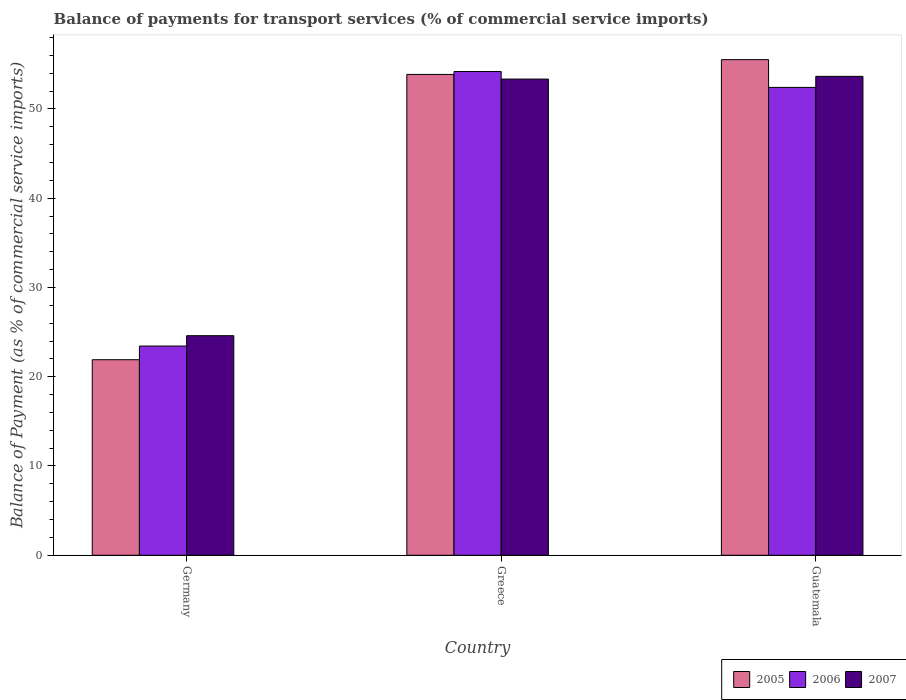How many groups of bars are there?
Give a very brief answer. 3. Are the number of bars per tick equal to the number of legend labels?
Your answer should be very brief. Yes. How many bars are there on the 1st tick from the left?
Provide a succinct answer. 3. How many bars are there on the 1st tick from the right?
Provide a succinct answer. 3. What is the label of the 3rd group of bars from the left?
Your answer should be very brief. Guatemala. In how many cases, is the number of bars for a given country not equal to the number of legend labels?
Your answer should be very brief. 0. What is the balance of payments for transport services in 2007 in Guatemala?
Make the answer very short. 53.64. Across all countries, what is the maximum balance of payments for transport services in 2007?
Keep it short and to the point. 53.64. Across all countries, what is the minimum balance of payments for transport services in 2007?
Your answer should be very brief. 24.6. In which country was the balance of payments for transport services in 2005 maximum?
Your answer should be very brief. Guatemala. What is the total balance of payments for transport services in 2006 in the graph?
Provide a short and direct response. 130.03. What is the difference between the balance of payments for transport services in 2006 in Greece and that in Guatemala?
Your response must be concise. 1.78. What is the difference between the balance of payments for transport services in 2006 in Greece and the balance of payments for transport services in 2005 in Germany?
Offer a very short reply. 32.28. What is the average balance of payments for transport services in 2006 per country?
Keep it short and to the point. 43.34. What is the difference between the balance of payments for transport services of/in 2007 and balance of payments for transport services of/in 2005 in Guatemala?
Provide a short and direct response. -1.87. In how many countries, is the balance of payments for transport services in 2006 greater than 22 %?
Make the answer very short. 3. What is the ratio of the balance of payments for transport services in 2006 in Germany to that in Greece?
Give a very brief answer. 0.43. What is the difference between the highest and the second highest balance of payments for transport services in 2005?
Make the answer very short. -31.95. What is the difference between the highest and the lowest balance of payments for transport services in 2005?
Make the answer very short. 33.61. In how many countries, is the balance of payments for transport services in 2005 greater than the average balance of payments for transport services in 2005 taken over all countries?
Your response must be concise. 2. Is the sum of the balance of payments for transport services in 2005 in Germany and Guatemala greater than the maximum balance of payments for transport services in 2007 across all countries?
Offer a very short reply. Yes. What does the 1st bar from the right in Guatemala represents?
Give a very brief answer. 2007. Is it the case that in every country, the sum of the balance of payments for transport services in 2006 and balance of payments for transport services in 2007 is greater than the balance of payments for transport services in 2005?
Offer a very short reply. Yes. How many bars are there?
Your answer should be very brief. 9. Are all the bars in the graph horizontal?
Provide a succinct answer. No. How many countries are there in the graph?
Provide a short and direct response. 3. Does the graph contain any zero values?
Offer a very short reply. No. Does the graph contain grids?
Offer a very short reply. No. Where does the legend appear in the graph?
Provide a succinct answer. Bottom right. How are the legend labels stacked?
Offer a terse response. Horizontal. What is the title of the graph?
Make the answer very short. Balance of payments for transport services (% of commercial service imports). What is the label or title of the Y-axis?
Make the answer very short. Balance of Payment (as % of commercial service imports). What is the Balance of Payment (as % of commercial service imports) in 2005 in Germany?
Make the answer very short. 21.91. What is the Balance of Payment (as % of commercial service imports) of 2006 in Germany?
Make the answer very short. 23.44. What is the Balance of Payment (as % of commercial service imports) in 2007 in Germany?
Keep it short and to the point. 24.6. What is the Balance of Payment (as % of commercial service imports) of 2005 in Greece?
Provide a succinct answer. 53.86. What is the Balance of Payment (as % of commercial service imports) in 2006 in Greece?
Your answer should be very brief. 54.19. What is the Balance of Payment (as % of commercial service imports) of 2007 in Greece?
Provide a succinct answer. 53.34. What is the Balance of Payment (as % of commercial service imports) in 2005 in Guatemala?
Provide a short and direct response. 55.52. What is the Balance of Payment (as % of commercial service imports) in 2006 in Guatemala?
Provide a short and direct response. 52.41. What is the Balance of Payment (as % of commercial service imports) in 2007 in Guatemala?
Provide a succinct answer. 53.64. Across all countries, what is the maximum Balance of Payment (as % of commercial service imports) of 2005?
Your answer should be compact. 55.52. Across all countries, what is the maximum Balance of Payment (as % of commercial service imports) of 2006?
Provide a short and direct response. 54.19. Across all countries, what is the maximum Balance of Payment (as % of commercial service imports) of 2007?
Provide a short and direct response. 53.64. Across all countries, what is the minimum Balance of Payment (as % of commercial service imports) in 2005?
Provide a short and direct response. 21.91. Across all countries, what is the minimum Balance of Payment (as % of commercial service imports) in 2006?
Offer a terse response. 23.44. Across all countries, what is the minimum Balance of Payment (as % of commercial service imports) of 2007?
Your answer should be compact. 24.6. What is the total Balance of Payment (as % of commercial service imports) in 2005 in the graph?
Give a very brief answer. 131.28. What is the total Balance of Payment (as % of commercial service imports) in 2006 in the graph?
Your answer should be compact. 130.03. What is the total Balance of Payment (as % of commercial service imports) of 2007 in the graph?
Your answer should be compact. 131.58. What is the difference between the Balance of Payment (as % of commercial service imports) in 2005 in Germany and that in Greece?
Your response must be concise. -31.95. What is the difference between the Balance of Payment (as % of commercial service imports) of 2006 in Germany and that in Greece?
Provide a short and direct response. -30.75. What is the difference between the Balance of Payment (as % of commercial service imports) of 2007 in Germany and that in Greece?
Offer a very short reply. -28.74. What is the difference between the Balance of Payment (as % of commercial service imports) of 2005 in Germany and that in Guatemala?
Offer a very short reply. -33.61. What is the difference between the Balance of Payment (as % of commercial service imports) of 2006 in Germany and that in Guatemala?
Make the answer very short. -28.97. What is the difference between the Balance of Payment (as % of commercial service imports) in 2007 in Germany and that in Guatemala?
Give a very brief answer. -29.05. What is the difference between the Balance of Payment (as % of commercial service imports) in 2005 in Greece and that in Guatemala?
Provide a short and direct response. -1.66. What is the difference between the Balance of Payment (as % of commercial service imports) of 2006 in Greece and that in Guatemala?
Your answer should be compact. 1.78. What is the difference between the Balance of Payment (as % of commercial service imports) of 2007 in Greece and that in Guatemala?
Ensure brevity in your answer.  -0.3. What is the difference between the Balance of Payment (as % of commercial service imports) of 2005 in Germany and the Balance of Payment (as % of commercial service imports) of 2006 in Greece?
Your answer should be very brief. -32.28. What is the difference between the Balance of Payment (as % of commercial service imports) in 2005 in Germany and the Balance of Payment (as % of commercial service imports) in 2007 in Greece?
Your response must be concise. -31.43. What is the difference between the Balance of Payment (as % of commercial service imports) in 2006 in Germany and the Balance of Payment (as % of commercial service imports) in 2007 in Greece?
Offer a very short reply. -29.9. What is the difference between the Balance of Payment (as % of commercial service imports) of 2005 in Germany and the Balance of Payment (as % of commercial service imports) of 2006 in Guatemala?
Your answer should be compact. -30.5. What is the difference between the Balance of Payment (as % of commercial service imports) in 2005 in Germany and the Balance of Payment (as % of commercial service imports) in 2007 in Guatemala?
Give a very brief answer. -31.74. What is the difference between the Balance of Payment (as % of commercial service imports) of 2006 in Germany and the Balance of Payment (as % of commercial service imports) of 2007 in Guatemala?
Keep it short and to the point. -30.21. What is the difference between the Balance of Payment (as % of commercial service imports) of 2005 in Greece and the Balance of Payment (as % of commercial service imports) of 2006 in Guatemala?
Provide a short and direct response. 1.45. What is the difference between the Balance of Payment (as % of commercial service imports) of 2005 in Greece and the Balance of Payment (as % of commercial service imports) of 2007 in Guatemala?
Make the answer very short. 0.22. What is the difference between the Balance of Payment (as % of commercial service imports) in 2006 in Greece and the Balance of Payment (as % of commercial service imports) in 2007 in Guatemala?
Give a very brief answer. 0.54. What is the average Balance of Payment (as % of commercial service imports) of 2005 per country?
Your answer should be very brief. 43.76. What is the average Balance of Payment (as % of commercial service imports) of 2006 per country?
Your response must be concise. 43.34. What is the average Balance of Payment (as % of commercial service imports) in 2007 per country?
Offer a very short reply. 43.86. What is the difference between the Balance of Payment (as % of commercial service imports) in 2005 and Balance of Payment (as % of commercial service imports) in 2006 in Germany?
Offer a terse response. -1.53. What is the difference between the Balance of Payment (as % of commercial service imports) of 2005 and Balance of Payment (as % of commercial service imports) of 2007 in Germany?
Keep it short and to the point. -2.69. What is the difference between the Balance of Payment (as % of commercial service imports) of 2006 and Balance of Payment (as % of commercial service imports) of 2007 in Germany?
Give a very brief answer. -1.16. What is the difference between the Balance of Payment (as % of commercial service imports) of 2005 and Balance of Payment (as % of commercial service imports) of 2006 in Greece?
Your answer should be compact. -0.33. What is the difference between the Balance of Payment (as % of commercial service imports) in 2005 and Balance of Payment (as % of commercial service imports) in 2007 in Greece?
Your answer should be compact. 0.52. What is the difference between the Balance of Payment (as % of commercial service imports) of 2006 and Balance of Payment (as % of commercial service imports) of 2007 in Greece?
Provide a succinct answer. 0.85. What is the difference between the Balance of Payment (as % of commercial service imports) in 2005 and Balance of Payment (as % of commercial service imports) in 2006 in Guatemala?
Ensure brevity in your answer.  3.11. What is the difference between the Balance of Payment (as % of commercial service imports) of 2005 and Balance of Payment (as % of commercial service imports) of 2007 in Guatemala?
Give a very brief answer. 1.87. What is the difference between the Balance of Payment (as % of commercial service imports) of 2006 and Balance of Payment (as % of commercial service imports) of 2007 in Guatemala?
Make the answer very short. -1.24. What is the ratio of the Balance of Payment (as % of commercial service imports) of 2005 in Germany to that in Greece?
Your answer should be very brief. 0.41. What is the ratio of the Balance of Payment (as % of commercial service imports) of 2006 in Germany to that in Greece?
Give a very brief answer. 0.43. What is the ratio of the Balance of Payment (as % of commercial service imports) of 2007 in Germany to that in Greece?
Ensure brevity in your answer.  0.46. What is the ratio of the Balance of Payment (as % of commercial service imports) of 2005 in Germany to that in Guatemala?
Give a very brief answer. 0.39. What is the ratio of the Balance of Payment (as % of commercial service imports) of 2006 in Germany to that in Guatemala?
Your answer should be compact. 0.45. What is the ratio of the Balance of Payment (as % of commercial service imports) of 2007 in Germany to that in Guatemala?
Give a very brief answer. 0.46. What is the ratio of the Balance of Payment (as % of commercial service imports) in 2005 in Greece to that in Guatemala?
Offer a terse response. 0.97. What is the ratio of the Balance of Payment (as % of commercial service imports) in 2006 in Greece to that in Guatemala?
Your answer should be compact. 1.03. What is the difference between the highest and the second highest Balance of Payment (as % of commercial service imports) in 2005?
Keep it short and to the point. 1.66. What is the difference between the highest and the second highest Balance of Payment (as % of commercial service imports) in 2006?
Your response must be concise. 1.78. What is the difference between the highest and the second highest Balance of Payment (as % of commercial service imports) in 2007?
Give a very brief answer. 0.3. What is the difference between the highest and the lowest Balance of Payment (as % of commercial service imports) of 2005?
Your answer should be compact. 33.61. What is the difference between the highest and the lowest Balance of Payment (as % of commercial service imports) of 2006?
Your answer should be compact. 30.75. What is the difference between the highest and the lowest Balance of Payment (as % of commercial service imports) of 2007?
Ensure brevity in your answer.  29.05. 